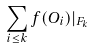Convert formula to latex. <formula><loc_0><loc_0><loc_500><loc_500>\sum _ { i \leq k } f ( O _ { i } ) | _ { F _ { k } }</formula> 